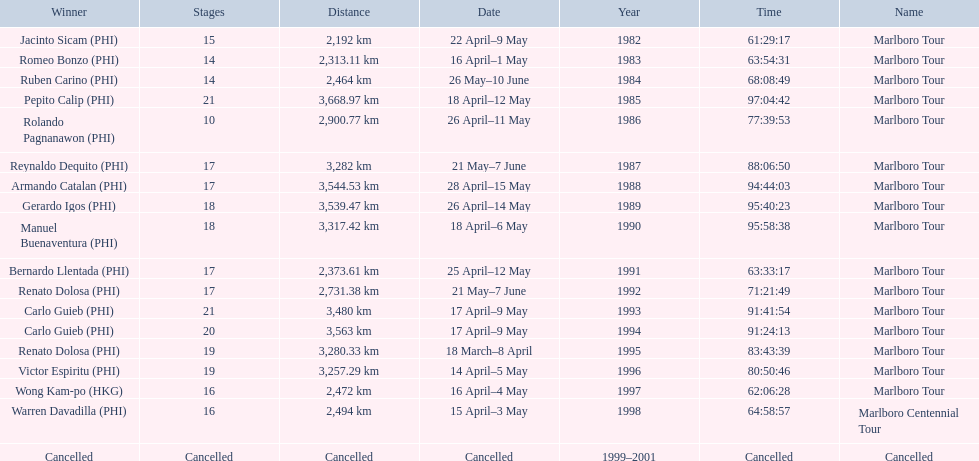What were the tour names during le tour de filipinas? Marlboro Tour, Marlboro Tour, Marlboro Tour, Marlboro Tour, Marlboro Tour, Marlboro Tour, Marlboro Tour, Marlboro Tour, Marlboro Tour, Marlboro Tour, Marlboro Tour, Marlboro Tour, Marlboro Tour, Marlboro Tour, Marlboro Tour, Marlboro Tour, Marlboro Centennial Tour, Cancelled. What were the recorded distances for each marlboro tour? 2,192 km, 2,313.11 km, 2,464 km, 3,668.97 km, 2,900.77 km, 3,282 km, 3,544.53 km, 3,539.47 km, 3,317.42 km, 2,373.61 km, 2,731.38 km, 3,480 km, 3,563 km, 3,280.33 km, 3,257.29 km, 2,472 km. And of those distances, which was the longest? 3,668.97 km. 